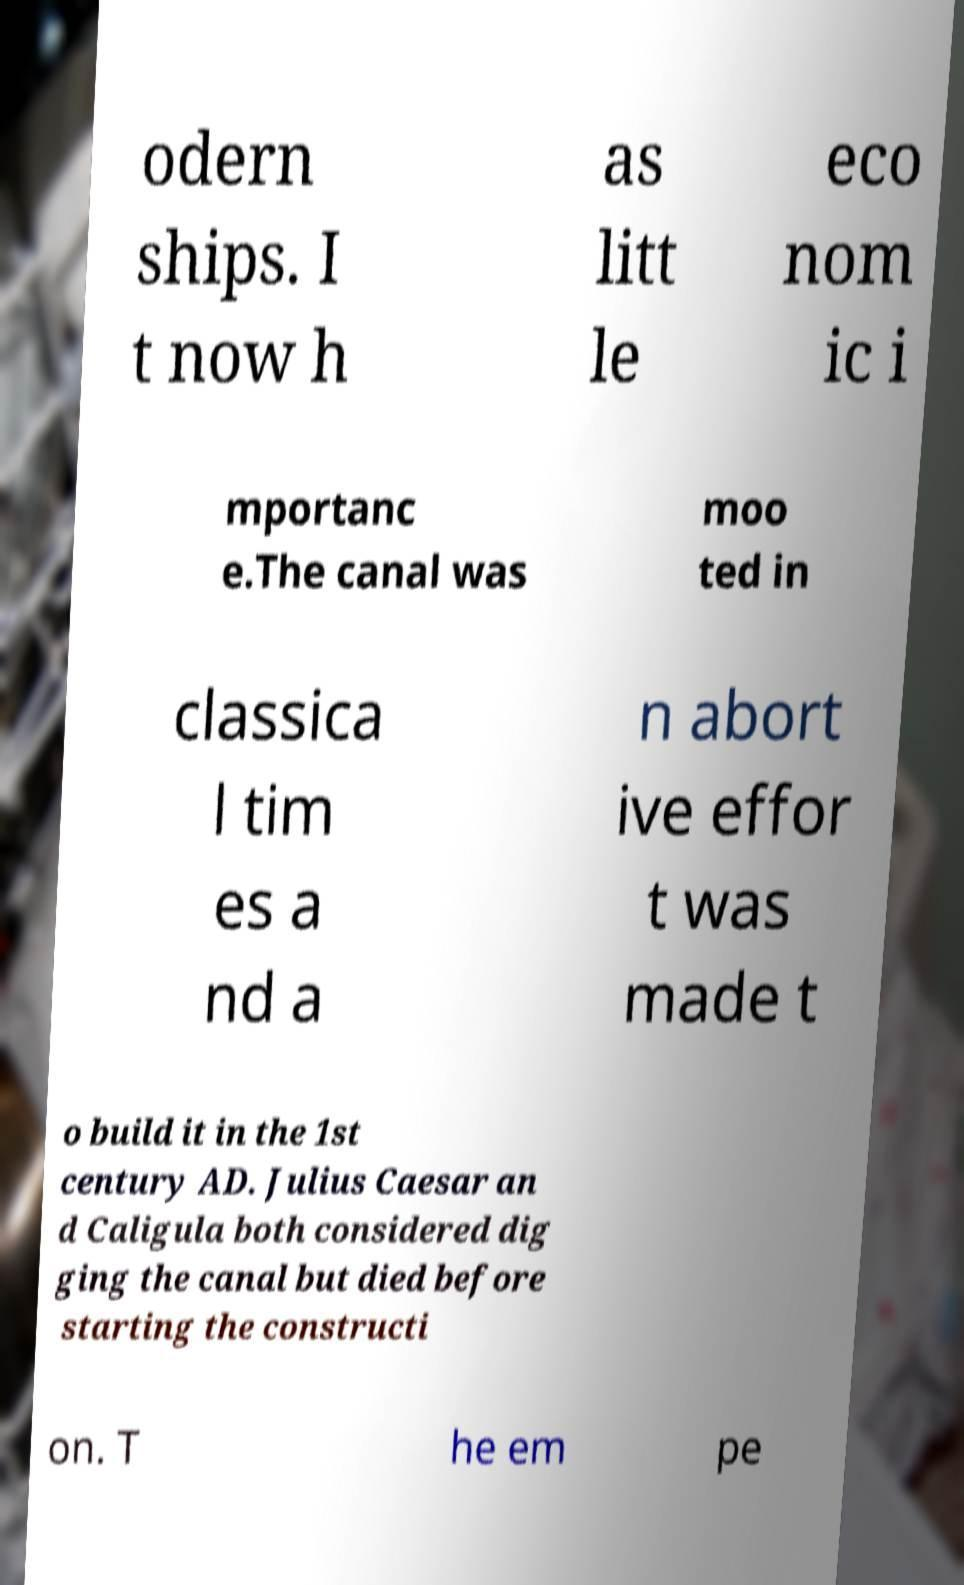Can you read and provide the text displayed in the image?This photo seems to have some interesting text. Can you extract and type it out for me? odern ships. I t now h as litt le eco nom ic i mportanc e.The canal was moo ted in classica l tim es a nd a n abort ive effor t was made t o build it in the 1st century AD. Julius Caesar an d Caligula both considered dig ging the canal but died before starting the constructi on. T he em pe 